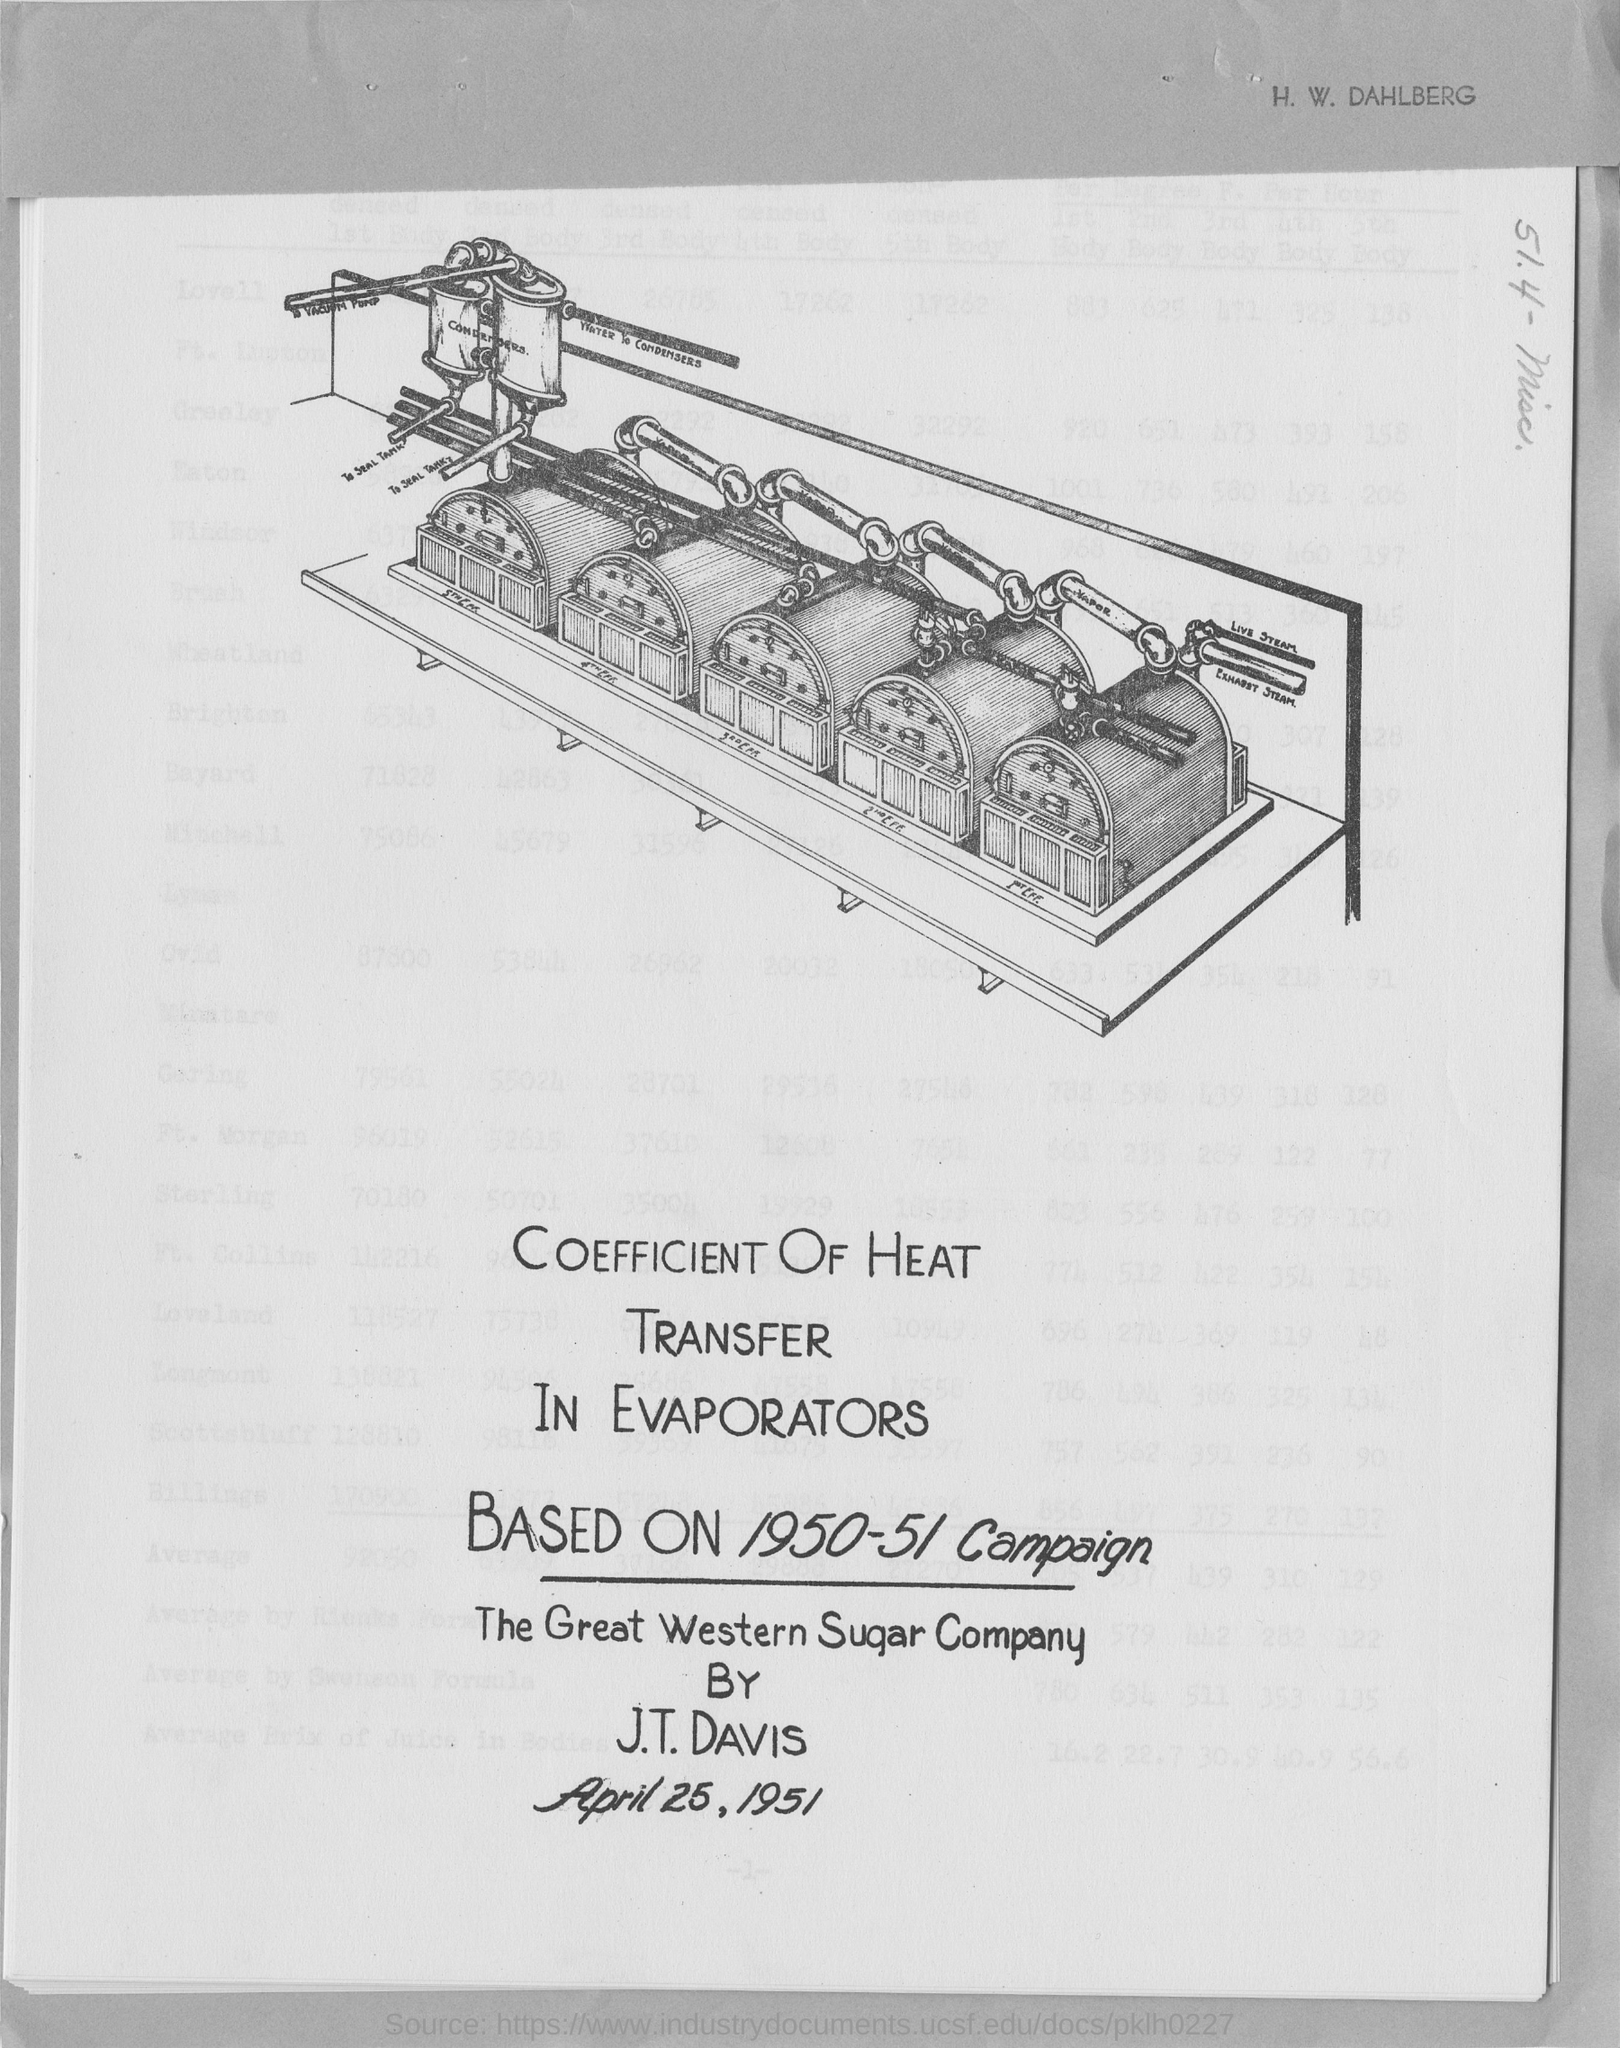Mention a couple of crucial points in this snapshot. The document in question provides information about a date, specifically April 25, 1951. 